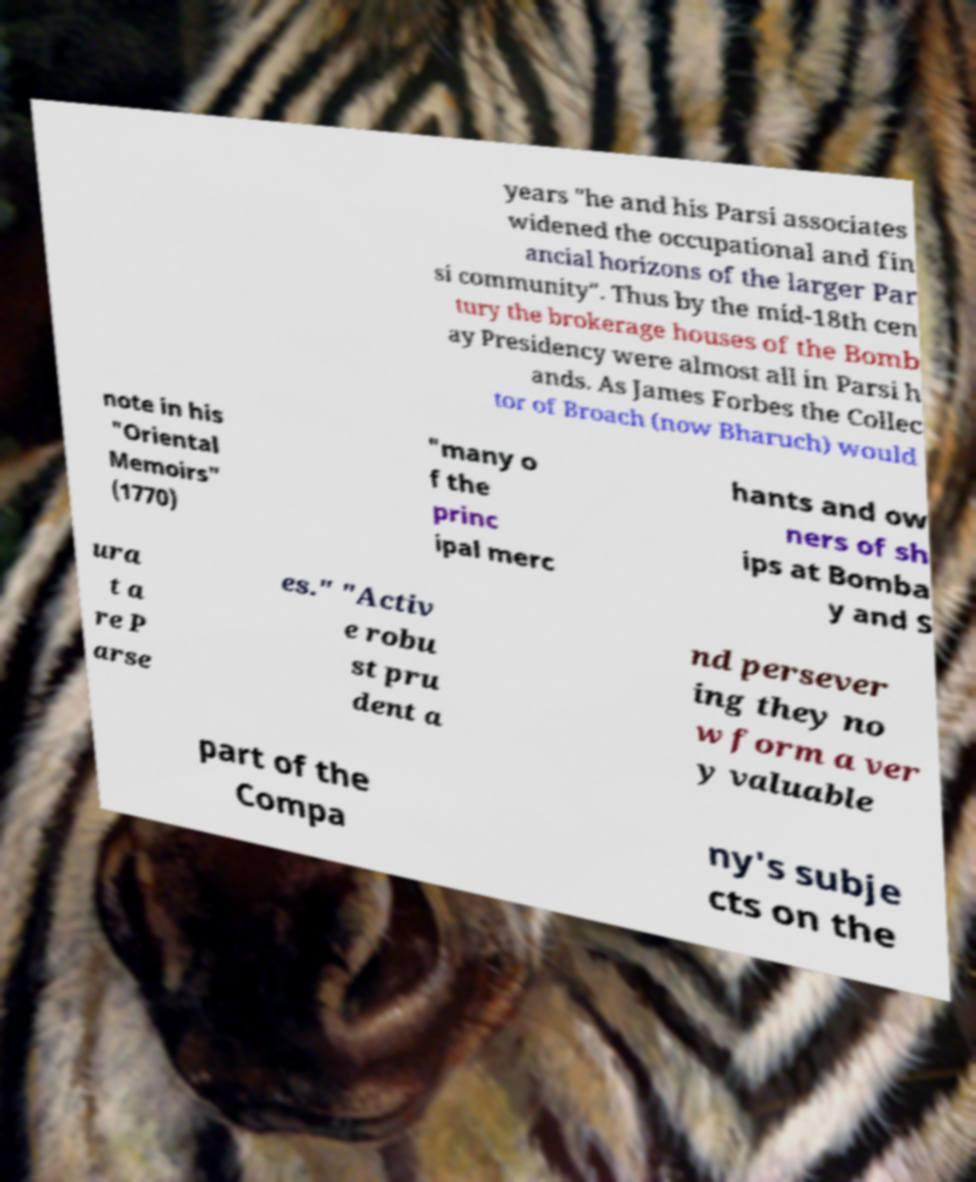Please identify and transcribe the text found in this image. years "he and his Parsi associates widened the occupational and fin ancial horizons of the larger Par si community". Thus by the mid-18th cen tury the brokerage houses of the Bomb ay Presidency were almost all in Parsi h ands. As James Forbes the Collec tor of Broach (now Bharuch) would note in his "Oriental Memoirs" (1770) "many o f the princ ipal merc hants and ow ners of sh ips at Bomba y and S ura t a re P arse es." "Activ e robu st pru dent a nd persever ing they no w form a ver y valuable part of the Compa ny's subje cts on the 